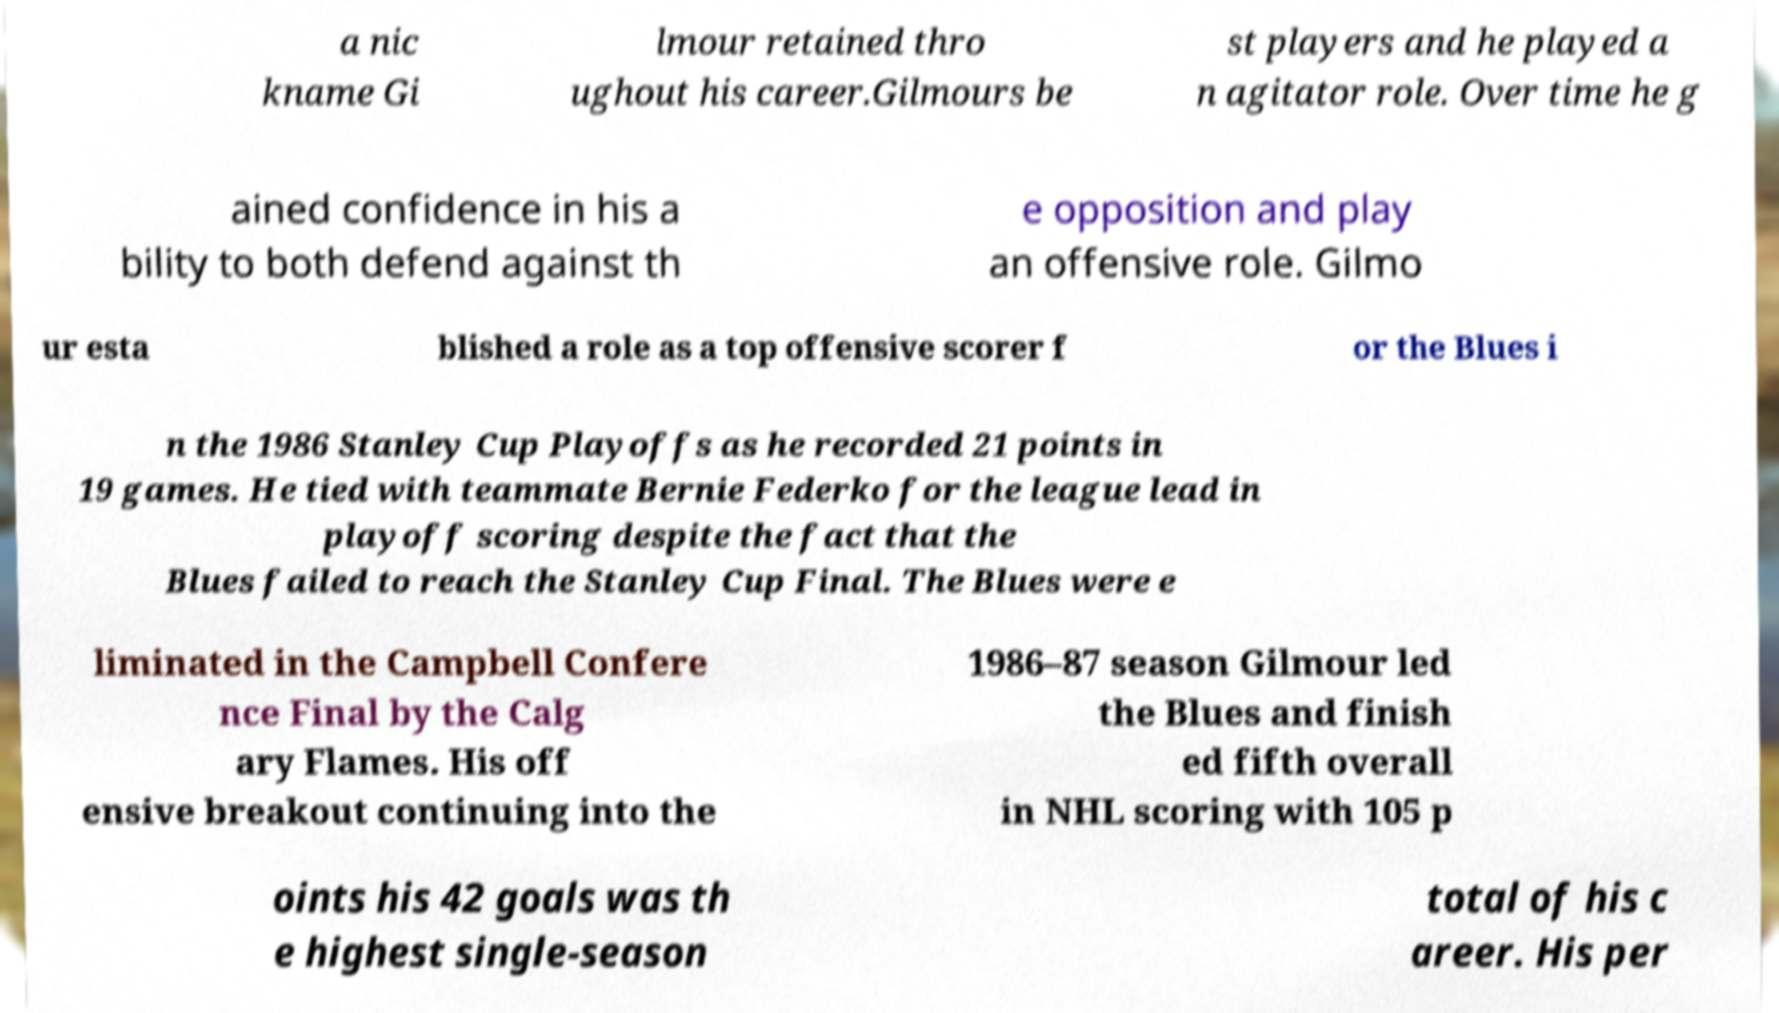Please read and relay the text visible in this image. What does it say? a nic kname Gi lmour retained thro ughout his career.Gilmours be st players and he played a n agitator role. Over time he g ained confidence in his a bility to both defend against th e opposition and play an offensive role. Gilmo ur esta blished a role as a top offensive scorer f or the Blues i n the 1986 Stanley Cup Playoffs as he recorded 21 points in 19 games. He tied with teammate Bernie Federko for the league lead in playoff scoring despite the fact that the Blues failed to reach the Stanley Cup Final. The Blues were e liminated in the Campbell Confere nce Final by the Calg ary Flames. His off ensive breakout continuing into the 1986–87 season Gilmour led the Blues and finish ed fifth overall in NHL scoring with 105 p oints his 42 goals was th e highest single-season total of his c areer. His per 